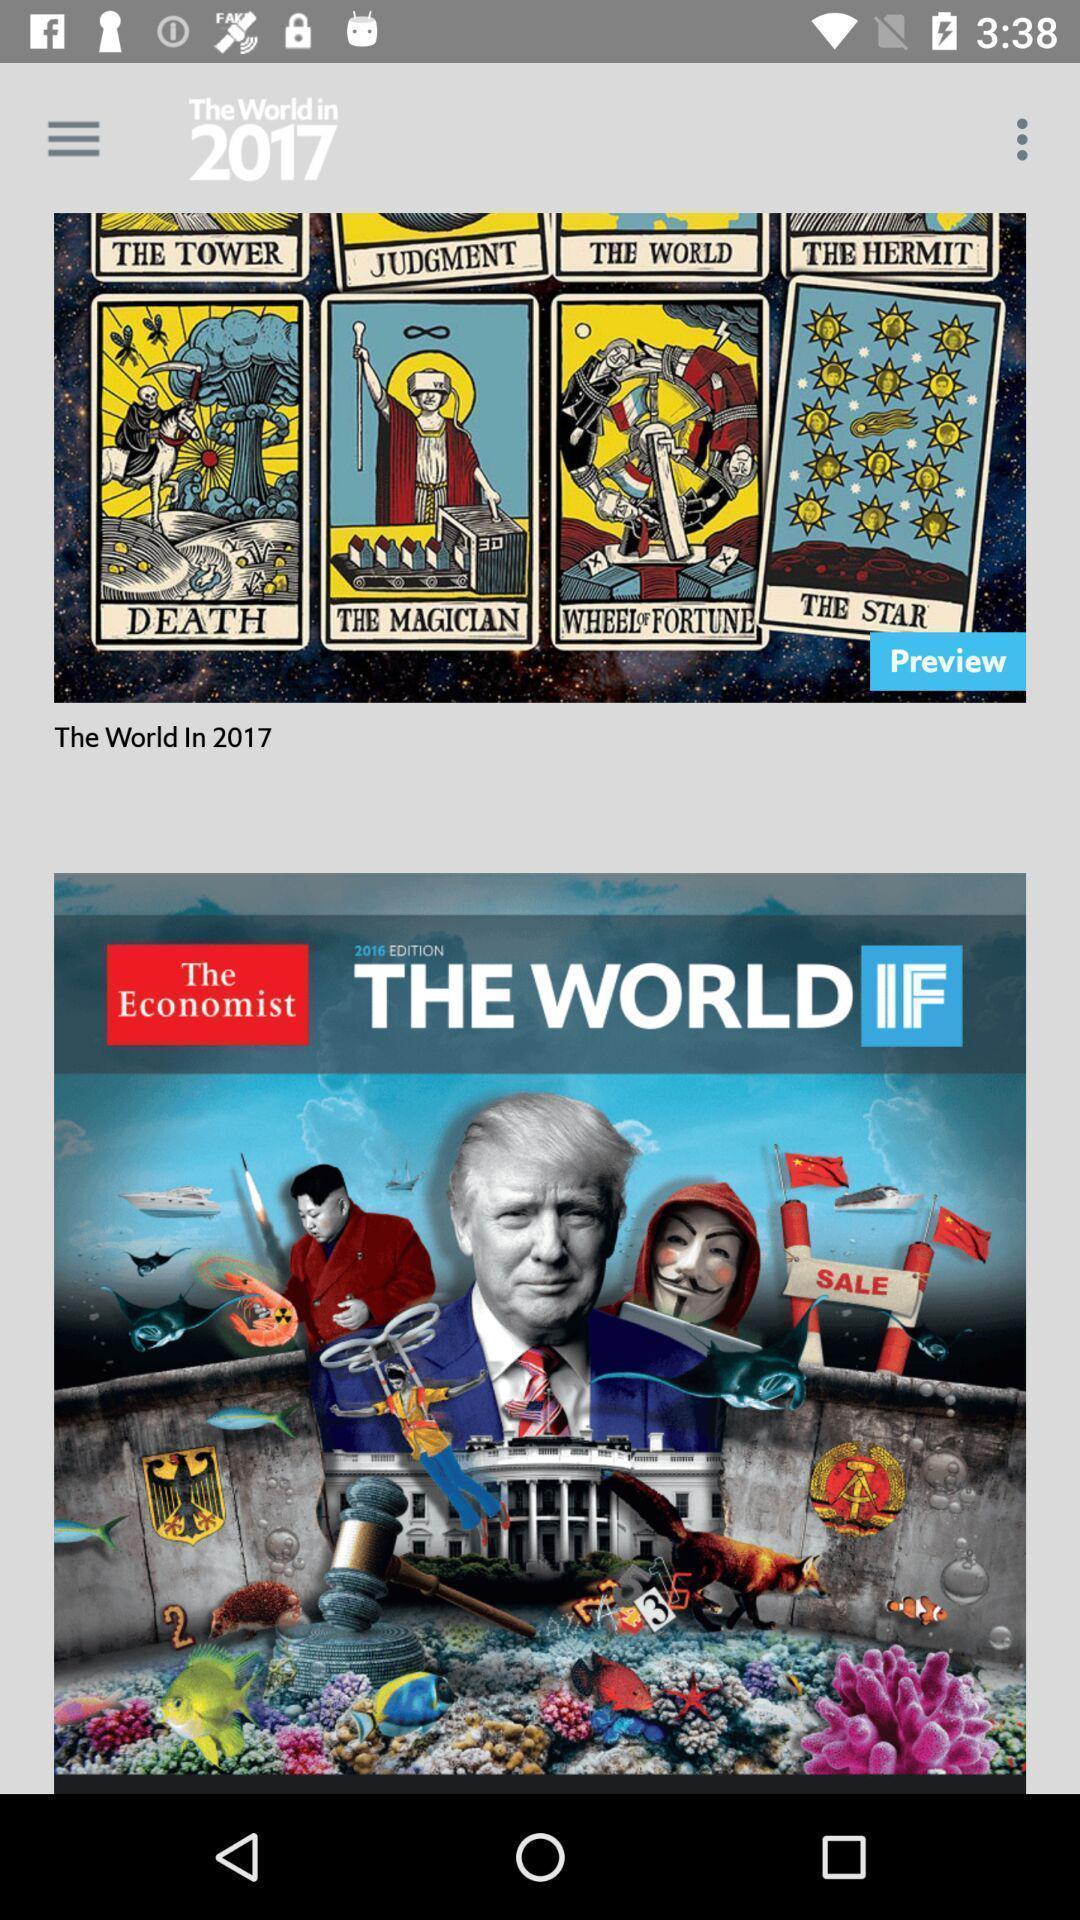Provide a textual representation of this image. Screen showing various books. 